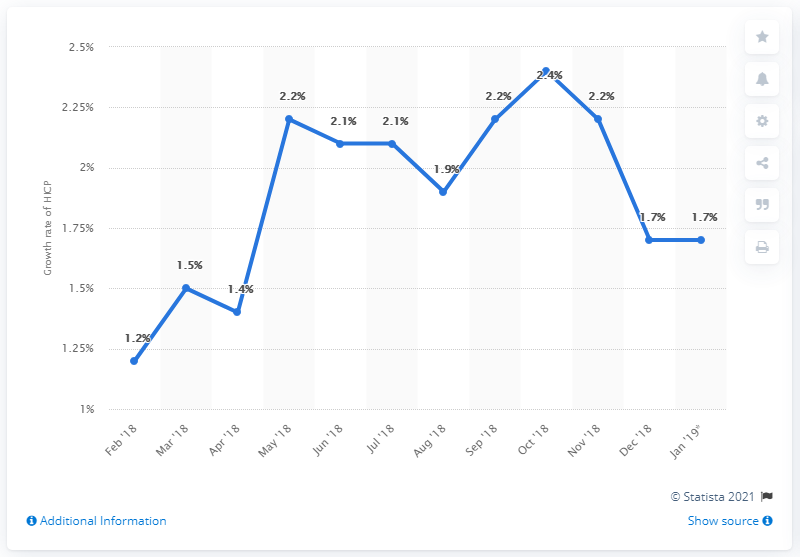List a handful of essential elements in this visual. The inflation rate in December 2018 was 1.7%. 